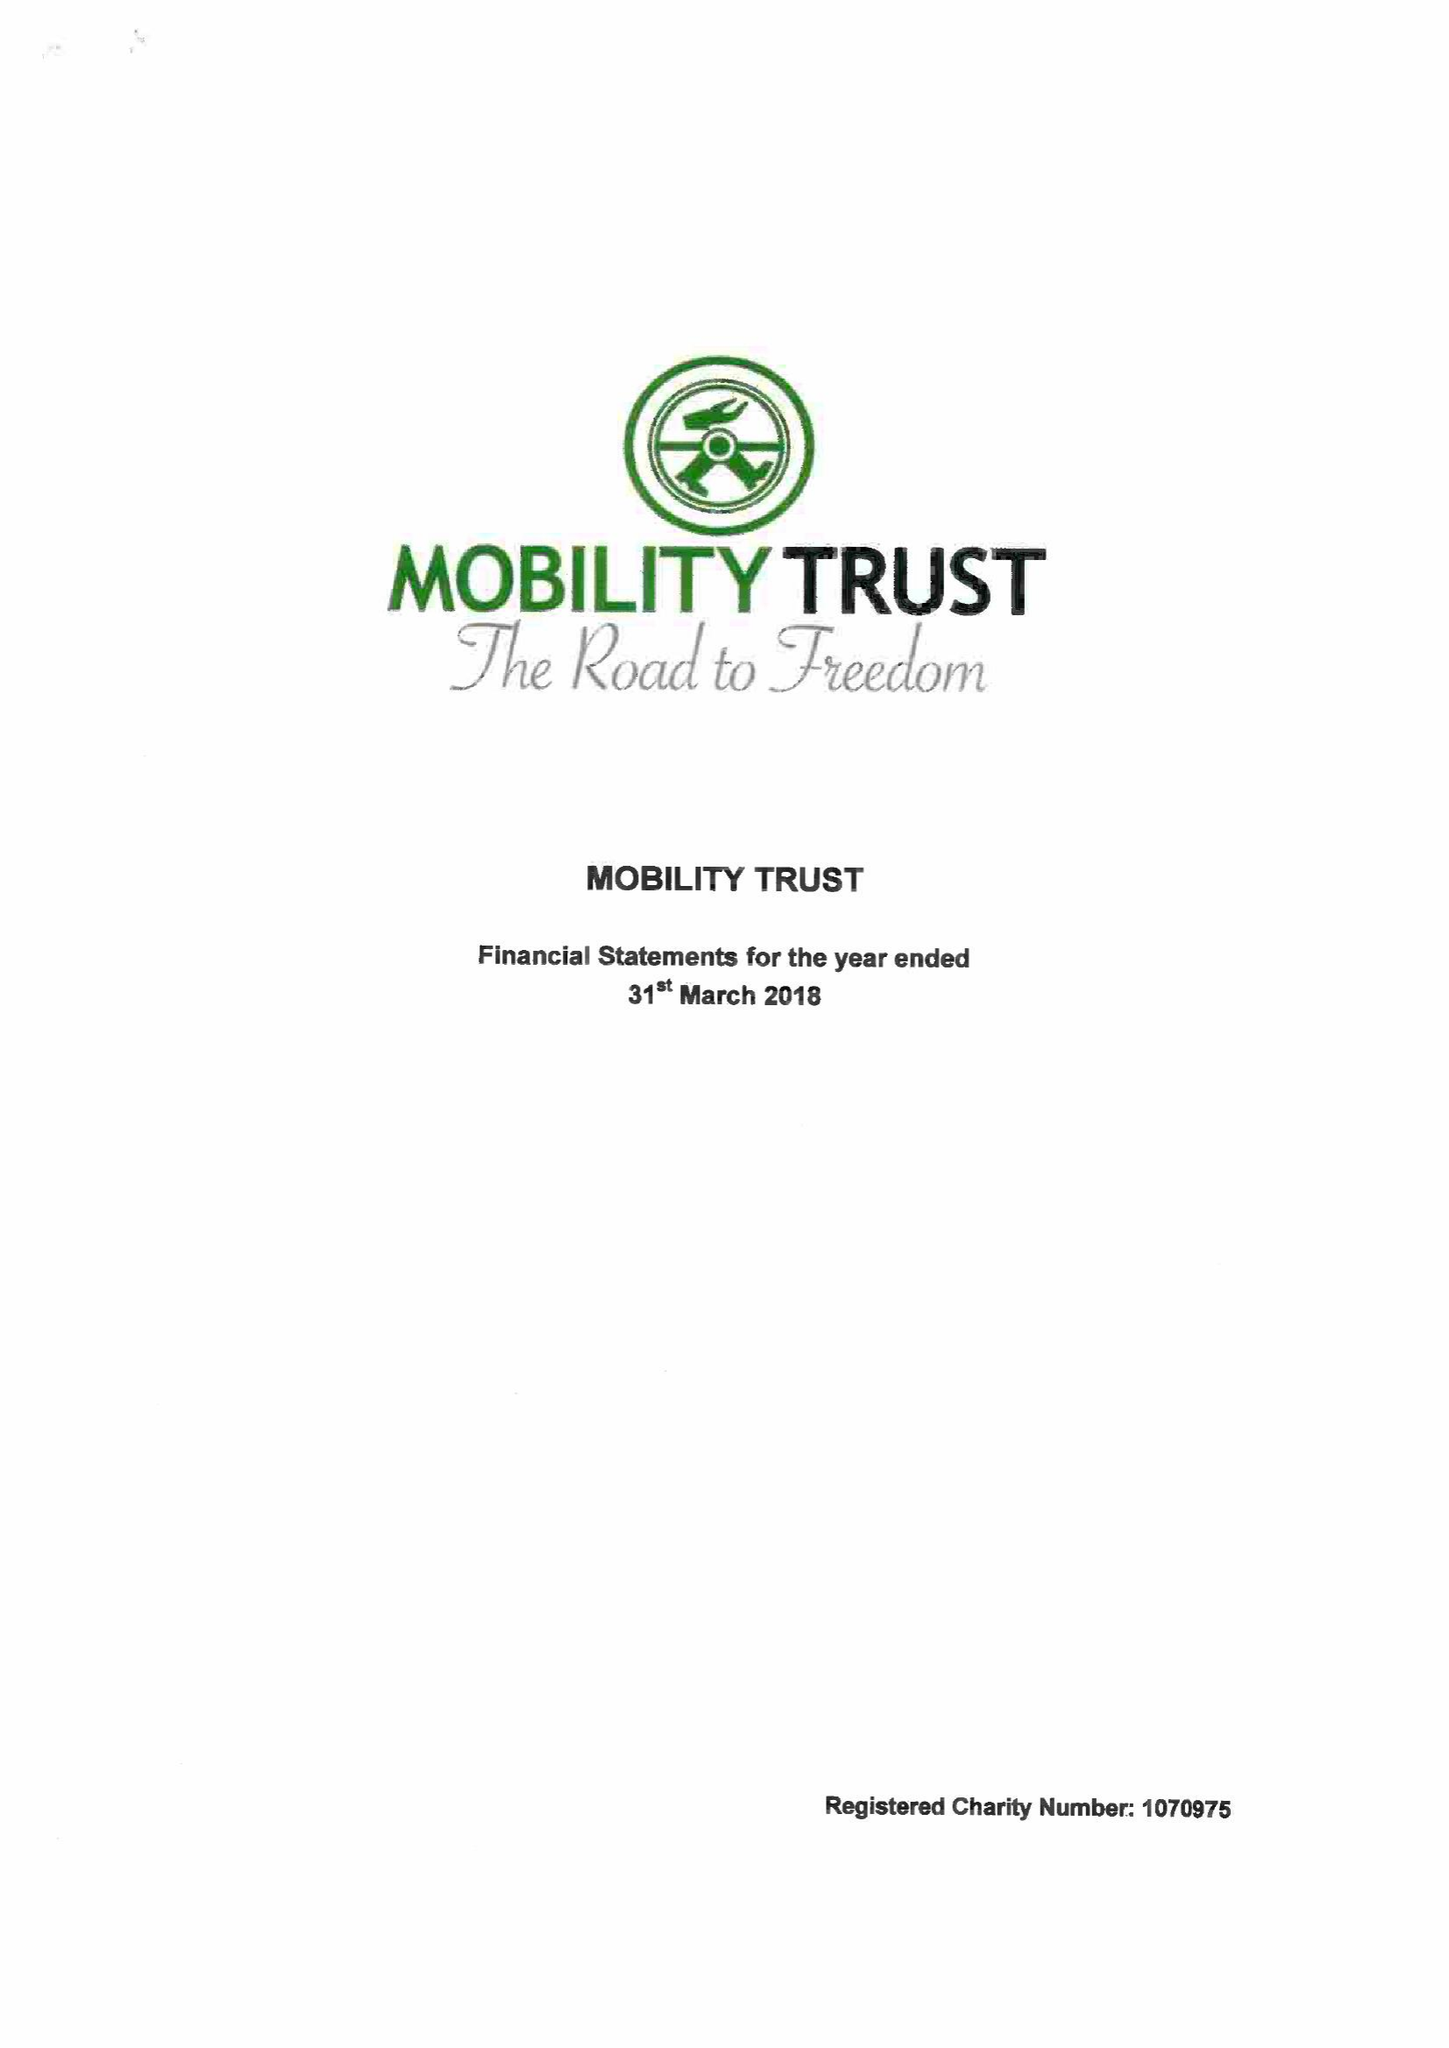What is the value for the address__post_town?
Answer the question using a single word or phrase. READING 